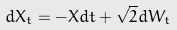<formula> <loc_0><loc_0><loc_500><loc_500>d X _ { t } = - X d t + \sqrt { 2 } d W _ { t }</formula> 